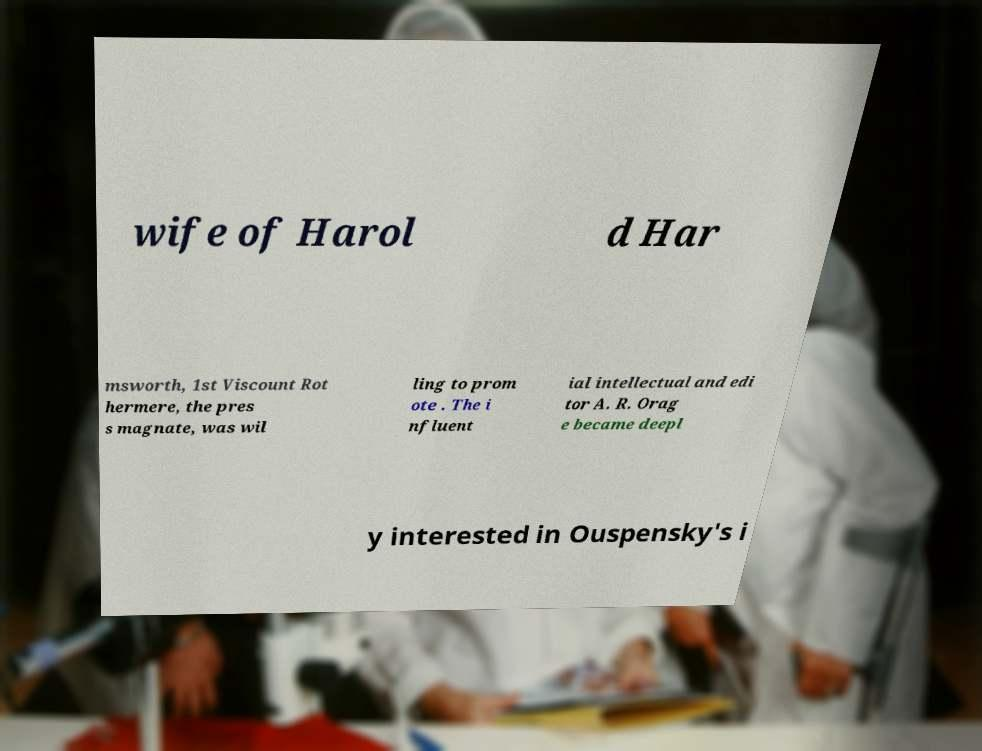Can you accurately transcribe the text from the provided image for me? wife of Harol d Har msworth, 1st Viscount Rot hermere, the pres s magnate, was wil ling to prom ote . The i nfluent ial intellectual and edi tor A. R. Orag e became deepl y interested in Ouspensky's i 